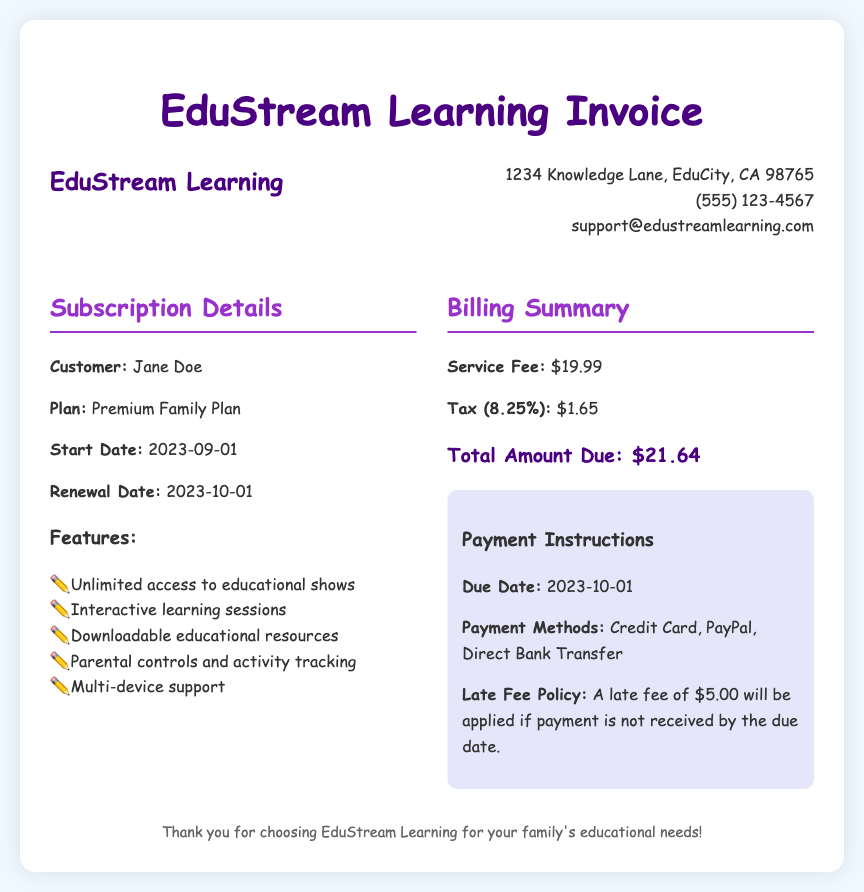What is the customer name? The customer's name is clearly stated in the subscription details section of the document.
Answer: Jane Doe What is the price of the service fee? The service fee is explicitly mentioned in the billing summary section of the document.
Answer: $19.99 What is the total amount due? The total amount due is provided at the end of the billing summary section.
Answer: $21.64 What is the tax rate applied? The tax rate is specified in the billing summary and is expressed as a percentage.
Answer: 8.25% When is the renewal date? The renewal date is highlighted in the subscription details and presents the next billing cycle.
Answer: 2023-10-01 What features are included in the subscription plan? A list of features is provided under the subscription details section; it highlights what this plan offers.
Answer: Unlimited access to educational shows, Interactive learning sessions, Downloadable educational resources, Parental controls and activity tracking, Multi-device support What happens if the payment is late? The policy regarding late fees is stated directly in the payment instructions section.
Answer: A late fee of $5.00 will be applied What payment methods are available? Payment methods are listed in the payment instructions part of the document.
Answer: Credit Card, PayPal, Direct Bank Transfer What is the due date for payment? The due date is stated in the payment instructions and indicates when payment must be made.
Answer: 2023-10-01 